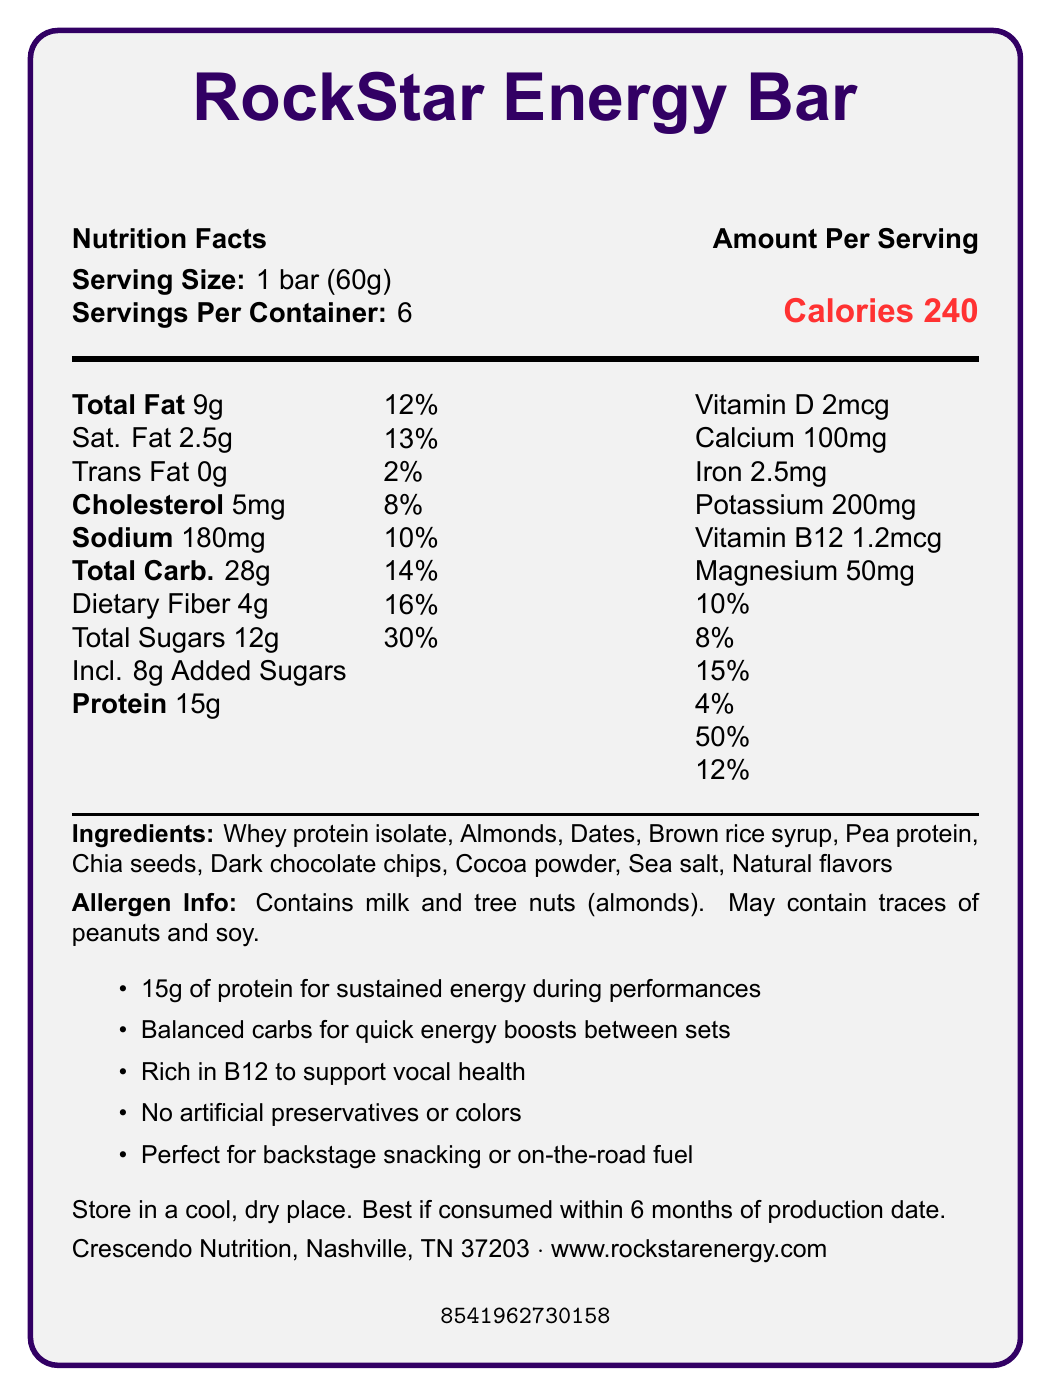What is the serving size of the RockStar Energy Bar? The serving size is clearly stated in the document as 1 bar (60g).
Answer: 1 bar (60g) How many servings are there per container? The document mentions that each container has 6 servings.
Answer: 6 How many grams of protein are in one serving of the RockStar Energy Bar? Under the nutrition facts, it states that there are 15g of protein per serving.
Answer: 15g What percentage of the daily value of Vitamin B12 does one serving provide? The document lists the daily value percentage for Vitamin B12 as 50%.
Answer: 50% Which ingredient listed is likely a key source of protein? One of the main ingredients is Whey protein isolate, which is known for being a high source of protein.
Answer: Whey protein isolate Which nutrient has the highest daily value percentage in one serving? A. Vitamin D B. Sodium C. Dietary Fiber D. Vitamin B12 Vitamin B12 has a daily value percentage of 50%, which is the highest listed in the document.
Answer: D. Vitamin B12 Which of the following is NOT an ingredient in the RockStar Energy Bar? A. Almonds B. Pea protein C. Honey D. Dates Honey is not listed; the document mentions Almonds, Pea protein, and Dates as ingredients but not Honey.
Answer: C. Honey Is there any cholesterol in a serving of the RockStar Energy Bar? The document states there is 5mg of cholesterol in one serving, with a 2% daily value.
Answer: Yes Does the RockStar Energy Bar contain any artificial preservatives or colors? The marketing claims specifically state that there are no artificial preservatives or colors.
Answer: No Summarize the main marketing claims made for the RockStar Energy Bar. The marketing section of the document highlights that the bar is protein-rich for sustained energy, has balanced carbohydrates for quick energy boosts, supports vocal health with Vitamin B12, contains no artificial preservatives or colors, and is ideal for musicians and performers.
Answer: The RockStar Energy Bar provides 15g of protein for sustained energy, balanced carbs for quick energy boosts, is rich in Vitamin B12 to support vocal health, contains no artificial preservatives or colors, and is perfect for backstage snacking or on-the-road fuel. How many total calories would you consume if you ate an entire container of RockStar Energy Bars? Since there are 6 servings in a container and each serving has 240 calories, multiplying 240 by 6 gives 1440 calories.
Answer: 1440 calories Does the RockStar Energy Bar contain any soy? The allergen info states that while the bar doesn't directly contain soy, it may contain traces of it.
Answer: May contain traces What is the total amount of sugars in one serving? The document lists total sugars as 12g per serving.
Answer: 12g Where is Crescendo Nutrition located? The manufacturer information provided at the end of the document states that Crescendo Nutrition is located in Nashville, TN 37203.
Answer: Nashville, TN 37203 What ingredient could support vocal health according to the marketing claims? The marketing claims highlight that the bar is rich in B12, which supports vocal health.
Answer: Vitamin B12 Are any organic ingredients used in the RockStar Energy Bar? The document does not provide explicit information whether the ingredients are organic or not.
Answer: Cannot be determined What is the storage instruction for maintaining the best taste and texture of the bar? The document states these storage instructions clearly under the storage section.
Answer: Store in a cool, dry place. Best if consumed within 6 months of production date. 